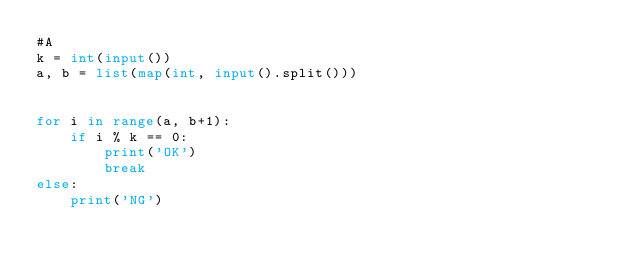Convert code to text. <code><loc_0><loc_0><loc_500><loc_500><_Python_>#A
k = int(input())
a, b = list(map(int, input().split()))


for i in range(a, b+1):
    if i % k == 0:
        print('OK')
        break
else:
    print('NG')</code> 